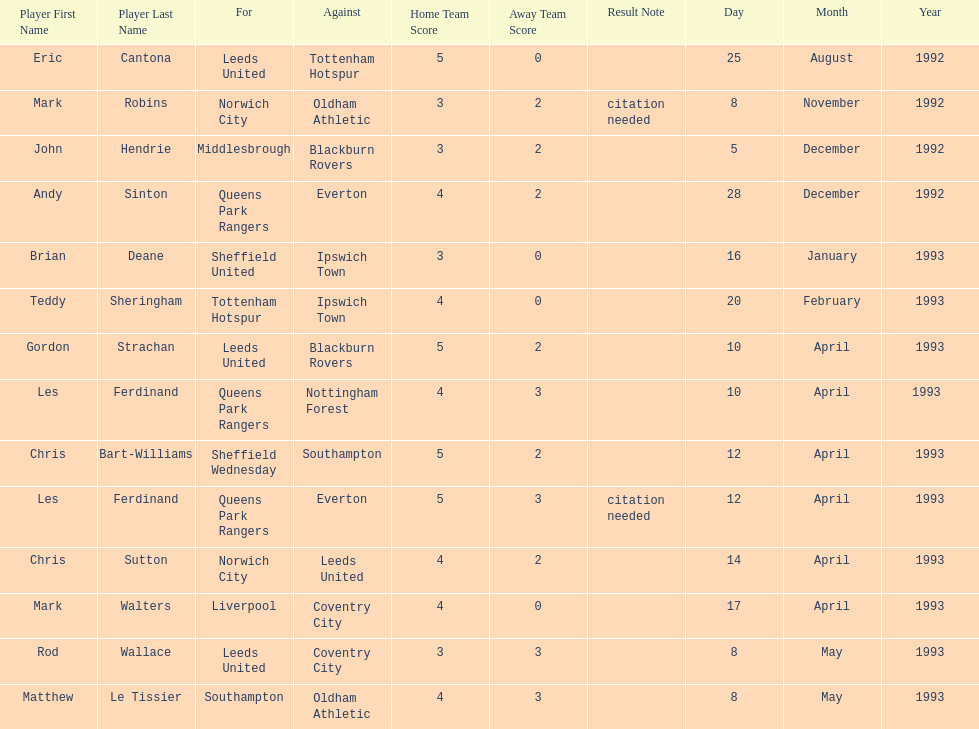Who are the players in 1992-93 fa premier league? Eric Cantona, Mark Robins, John Hendrie, Andy Sinton, Brian Deane, Teddy Sheringham, Gordon Strachan, Les Ferdinand, Chris Bart-Williams, Les Ferdinand, Chris Sutton, Mark Walters, Rod Wallace, Matthew Le Tissier. What is mark robins' result? 3–2[citation needed]. Which player has the same result? John Hendrie. 